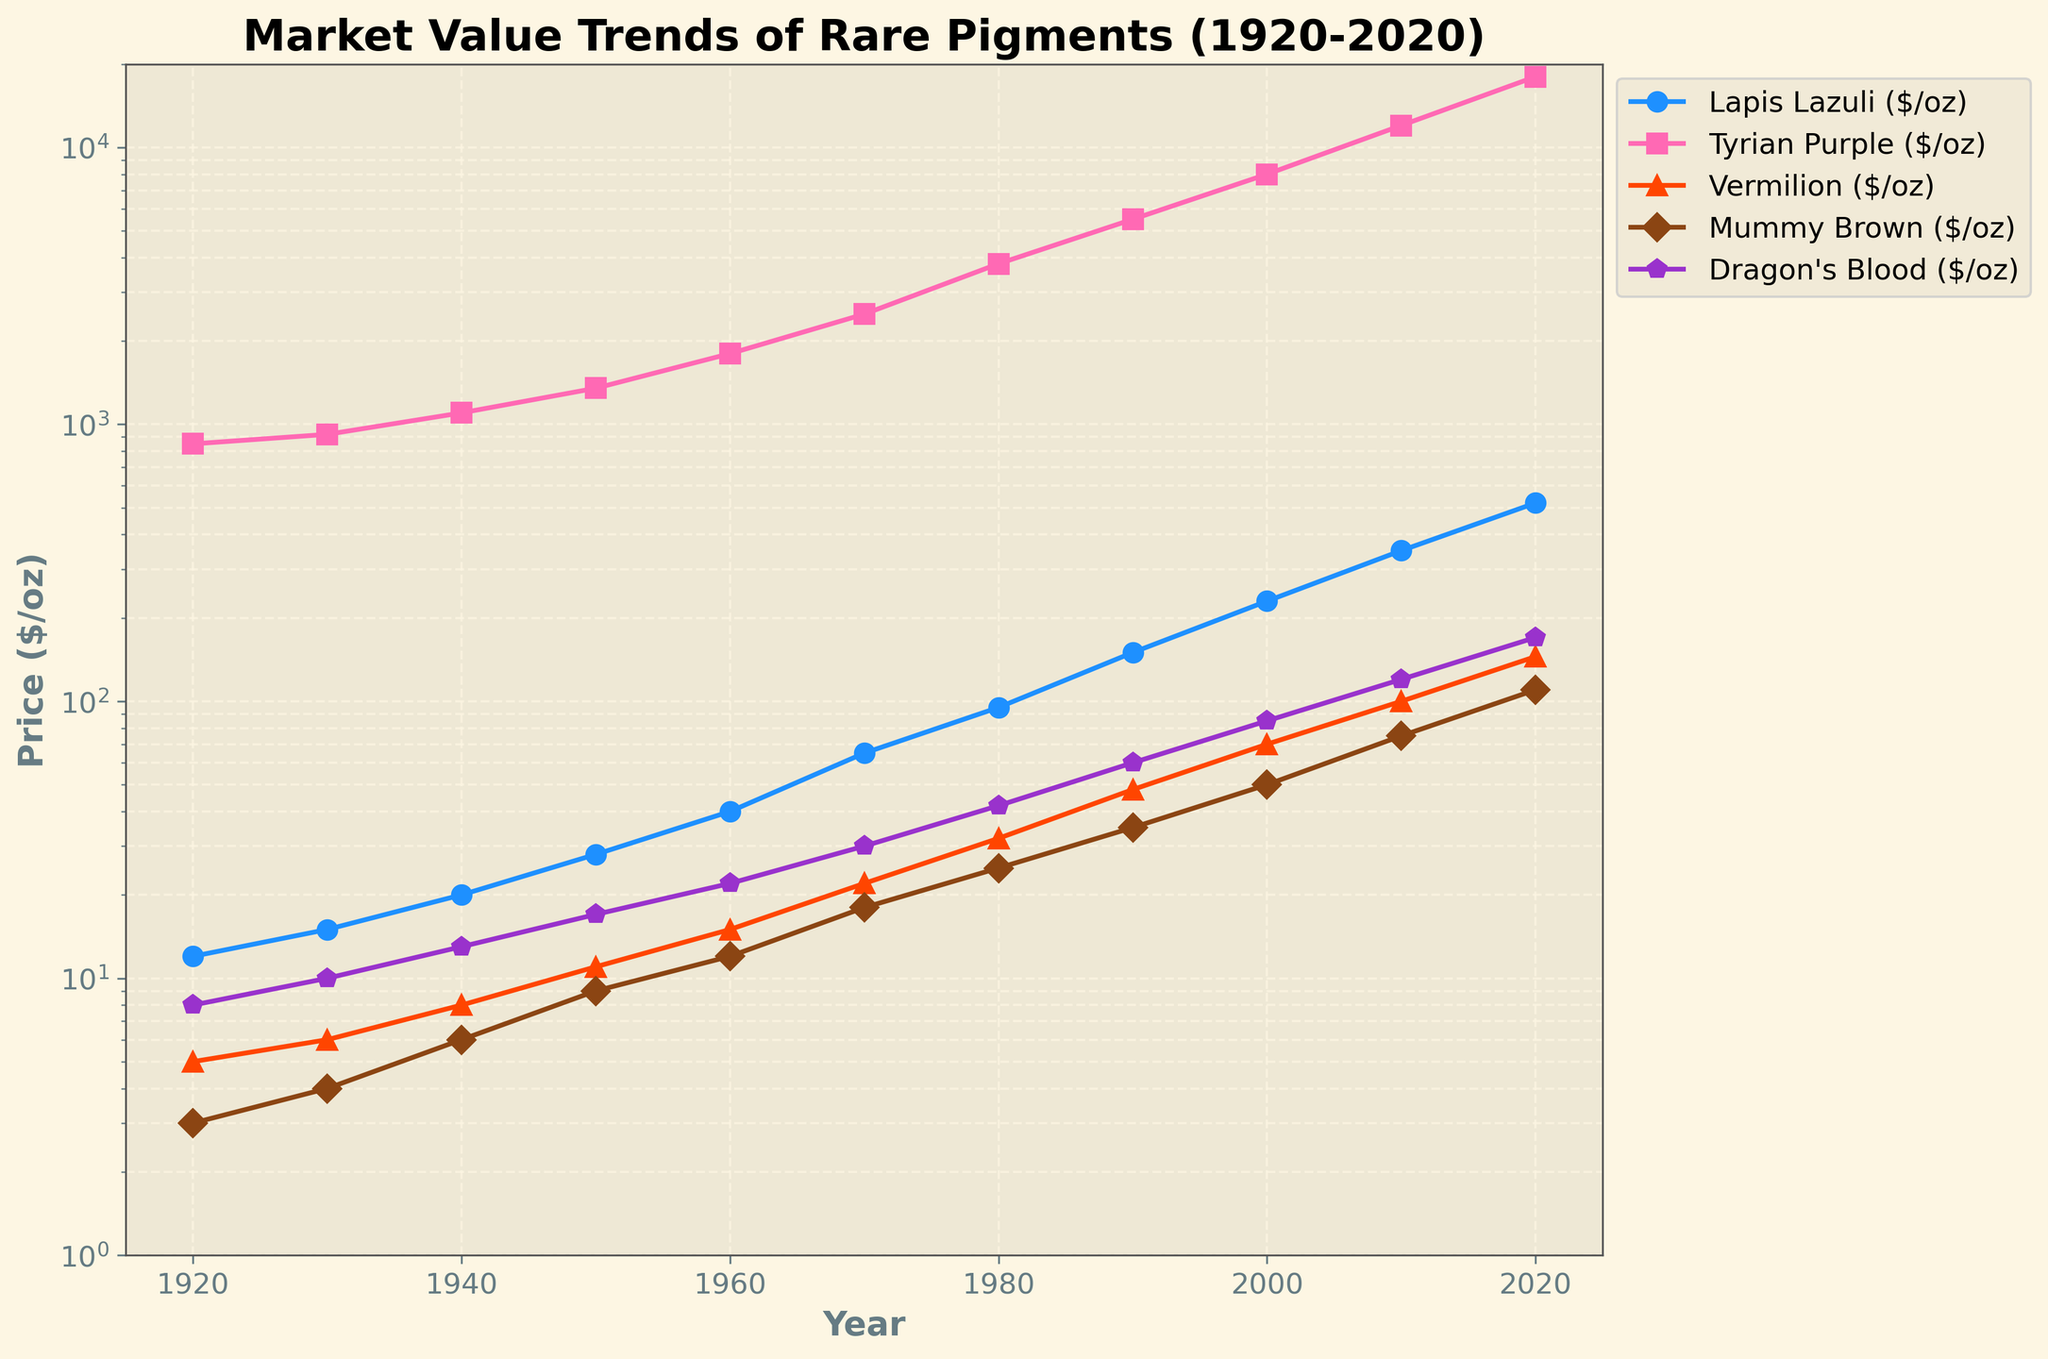Which pigment had the highest market value in 2020? By looking at the end of the horizontal axis and finding the largest value on the vertical axis, we see that Tyrian Purple has the highest price in 2020.
Answer: Tyrian Purple Between which years did Lapis Lazuli experience the fastest price increase? By observing the steepness of the curve for Lapis Lazuli, the period between 1990 and 2020 shows the sharpest increase.
Answer: 1990-2020 What is the price difference of Vermilion between 2000 and 2020? Find the Vermilion prices for the years 2000 and 2020 and calculate the difference: 145 (2020) - 70 (2000) = 75.
Answer: 75 Which pigment had the smallest price increase from 1920 to 2020? By comparing the differences in prices from 1920 to 2020 for each pigment, Mummy Brown shows the smallest increase: 110 (2020) - 3 (1920) = 107.
Answer: Mummy Brown How does the price trend of Dragon's Blood compare to Lapis Lazuli? By examining the graph, both Dragon's Blood and Lapis Lazuli show an increasing trend, but Dragon's Blood increases more steadily, while Lapis Lazuli's rise is more exponential.
Answer: Both increase, Lapis Lazuli more exponentially What was the market value of Tyrian Purple in 1950? Locate the year 1950 on the horizontal axis and trace the value of Tyrian Purple on the vertical axis, which is approximately 1350.
Answer: 1350 In which decade did Vermilion exceed 100 $/oz? By following the curve for Vermilion, it crosses the 100 $/oz mark between 2010 and 2020.
Answer: 2010-2020 Which pigment had a price below 10 $/oz in 1940? Observe the price values for 1940 and check which pigments are below 10 $/oz. Vermilion (8 $/oz) and Mummy Brown (6 $/oz) both fall below this threshold.
Answer: Vermilion and Mummy Brown What is the average price of Dragon's Blood over the years provided? Sum all price values for Dragon's Blood and divide by the number of years: (8+10+13+17+22+30+42+60+85+120+170)/11 = 51.91.
Answer: 51.91 How does the price of Mummy Brown in 1930 compare to that in 1960? The price of Mummy Brown in 1930 is 4 $/oz while in 1960 it is 12 $/oz, showing that the price in 1960 is three times higher.
Answer: Three times higher 